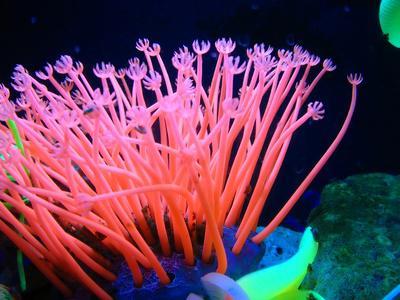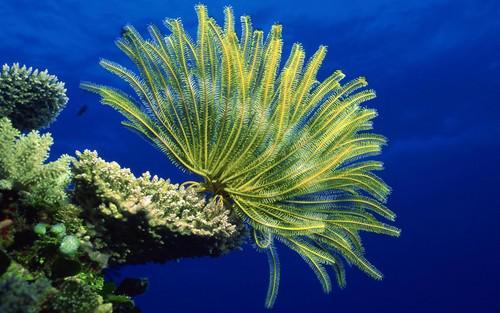The first image is the image on the left, the second image is the image on the right. For the images displayed, is the sentence "White striped fish swim among anemones." factually correct? Answer yes or no. No. The first image is the image on the left, the second image is the image on the right. Assess this claim about the two images: "fish are swimming near anemones". Correct or not? Answer yes or no. No. The first image is the image on the left, the second image is the image on the right. For the images displayed, is the sentence "There are red stones on the sea floor." factually correct? Answer yes or no. No. 